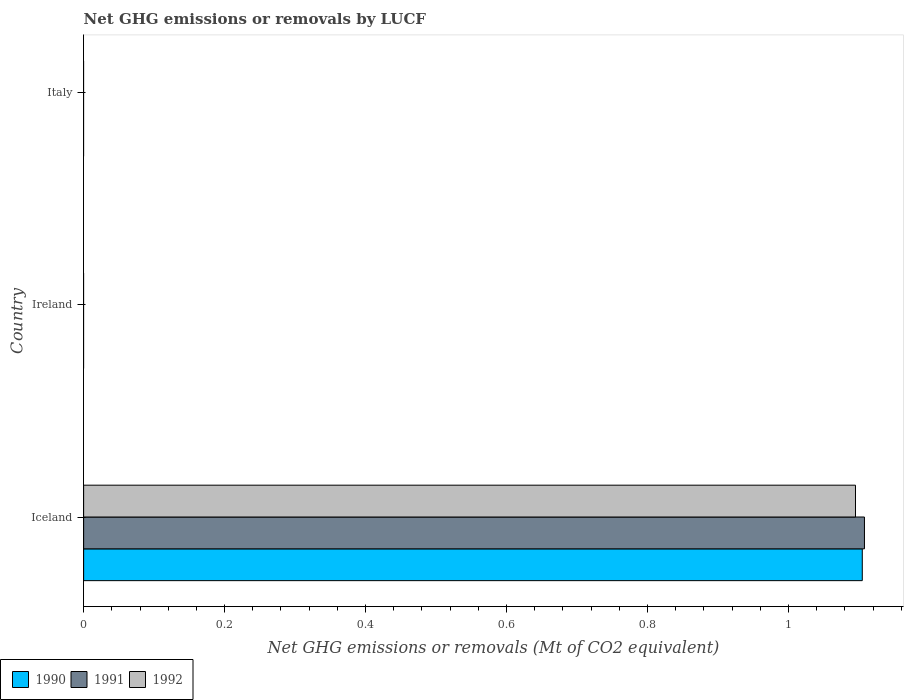Are the number of bars on each tick of the Y-axis equal?
Your answer should be very brief. No. How many bars are there on the 3rd tick from the top?
Offer a terse response. 3. How many bars are there on the 2nd tick from the bottom?
Offer a terse response. 0. In how many cases, is the number of bars for a given country not equal to the number of legend labels?
Your answer should be compact. 2. What is the net GHG emissions or removals by LUCF in 1992 in Italy?
Your answer should be compact. 0. Across all countries, what is the maximum net GHG emissions or removals by LUCF in 1991?
Offer a terse response. 1.11. What is the total net GHG emissions or removals by LUCF in 1991 in the graph?
Offer a very short reply. 1.11. What is the difference between the net GHG emissions or removals by LUCF in 1990 in Italy and the net GHG emissions or removals by LUCF in 1991 in Iceland?
Give a very brief answer. -1.11. What is the average net GHG emissions or removals by LUCF in 1992 per country?
Keep it short and to the point. 0.37. What is the difference between the net GHG emissions or removals by LUCF in 1990 and net GHG emissions or removals by LUCF in 1991 in Iceland?
Give a very brief answer. -0. What is the difference between the highest and the lowest net GHG emissions or removals by LUCF in 1992?
Your answer should be compact. 1.1. In how many countries, is the net GHG emissions or removals by LUCF in 1992 greater than the average net GHG emissions or removals by LUCF in 1992 taken over all countries?
Your response must be concise. 1. Is it the case that in every country, the sum of the net GHG emissions or removals by LUCF in 1992 and net GHG emissions or removals by LUCF in 1991 is greater than the net GHG emissions or removals by LUCF in 1990?
Give a very brief answer. No. How many bars are there?
Your answer should be very brief. 3. Are all the bars in the graph horizontal?
Your response must be concise. Yes. How many countries are there in the graph?
Provide a short and direct response. 3. Are the values on the major ticks of X-axis written in scientific E-notation?
Your response must be concise. No. Where does the legend appear in the graph?
Your answer should be compact. Bottom left. What is the title of the graph?
Offer a terse response. Net GHG emissions or removals by LUCF. Does "2001" appear as one of the legend labels in the graph?
Provide a succinct answer. No. What is the label or title of the X-axis?
Your answer should be compact. Net GHG emissions or removals (Mt of CO2 equivalent). What is the Net GHG emissions or removals (Mt of CO2 equivalent) in 1990 in Iceland?
Your answer should be compact. 1.1. What is the Net GHG emissions or removals (Mt of CO2 equivalent) in 1991 in Iceland?
Your answer should be compact. 1.11. What is the Net GHG emissions or removals (Mt of CO2 equivalent) of 1992 in Iceland?
Your response must be concise. 1.1. What is the Net GHG emissions or removals (Mt of CO2 equivalent) in 1991 in Ireland?
Give a very brief answer. 0. What is the Net GHG emissions or removals (Mt of CO2 equivalent) in 1992 in Ireland?
Provide a succinct answer. 0. What is the Net GHG emissions or removals (Mt of CO2 equivalent) in 1990 in Italy?
Ensure brevity in your answer.  0. Across all countries, what is the maximum Net GHG emissions or removals (Mt of CO2 equivalent) of 1990?
Offer a terse response. 1.1. Across all countries, what is the maximum Net GHG emissions or removals (Mt of CO2 equivalent) in 1991?
Provide a succinct answer. 1.11. Across all countries, what is the maximum Net GHG emissions or removals (Mt of CO2 equivalent) of 1992?
Offer a very short reply. 1.1. Across all countries, what is the minimum Net GHG emissions or removals (Mt of CO2 equivalent) of 1990?
Provide a short and direct response. 0. What is the total Net GHG emissions or removals (Mt of CO2 equivalent) of 1990 in the graph?
Your response must be concise. 1.1. What is the total Net GHG emissions or removals (Mt of CO2 equivalent) in 1991 in the graph?
Make the answer very short. 1.11. What is the total Net GHG emissions or removals (Mt of CO2 equivalent) in 1992 in the graph?
Keep it short and to the point. 1.1. What is the average Net GHG emissions or removals (Mt of CO2 equivalent) of 1990 per country?
Provide a short and direct response. 0.37. What is the average Net GHG emissions or removals (Mt of CO2 equivalent) in 1991 per country?
Ensure brevity in your answer.  0.37. What is the average Net GHG emissions or removals (Mt of CO2 equivalent) in 1992 per country?
Offer a very short reply. 0.36. What is the difference between the Net GHG emissions or removals (Mt of CO2 equivalent) in 1990 and Net GHG emissions or removals (Mt of CO2 equivalent) in 1991 in Iceland?
Offer a very short reply. -0. What is the difference between the Net GHG emissions or removals (Mt of CO2 equivalent) in 1990 and Net GHG emissions or removals (Mt of CO2 equivalent) in 1992 in Iceland?
Give a very brief answer. 0.01. What is the difference between the Net GHG emissions or removals (Mt of CO2 equivalent) of 1991 and Net GHG emissions or removals (Mt of CO2 equivalent) of 1992 in Iceland?
Your response must be concise. 0.01. What is the difference between the highest and the lowest Net GHG emissions or removals (Mt of CO2 equivalent) in 1990?
Keep it short and to the point. 1.1. What is the difference between the highest and the lowest Net GHG emissions or removals (Mt of CO2 equivalent) in 1991?
Provide a short and direct response. 1.11. What is the difference between the highest and the lowest Net GHG emissions or removals (Mt of CO2 equivalent) in 1992?
Your answer should be very brief. 1.1. 